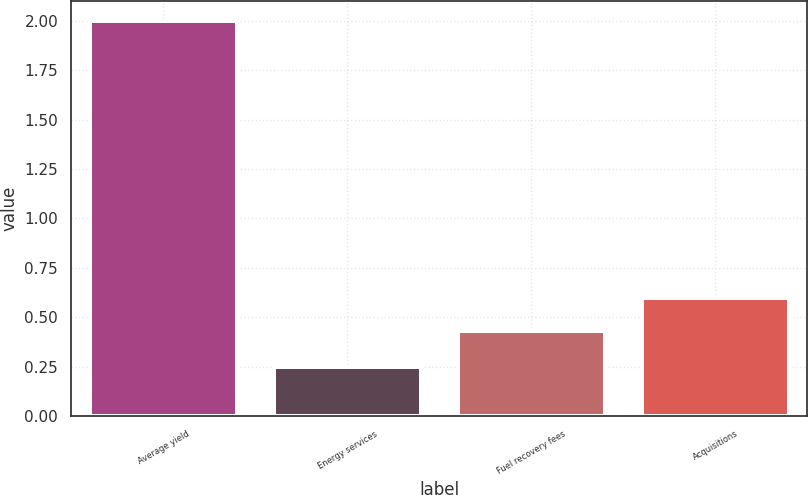Convert chart. <chart><loc_0><loc_0><loc_500><loc_500><bar_chart><fcel>Average yield<fcel>Energy services<fcel>Fuel recovery fees<fcel>Acquisitions<nl><fcel>2<fcel>0.25<fcel>0.43<fcel>0.6<nl></chart> 